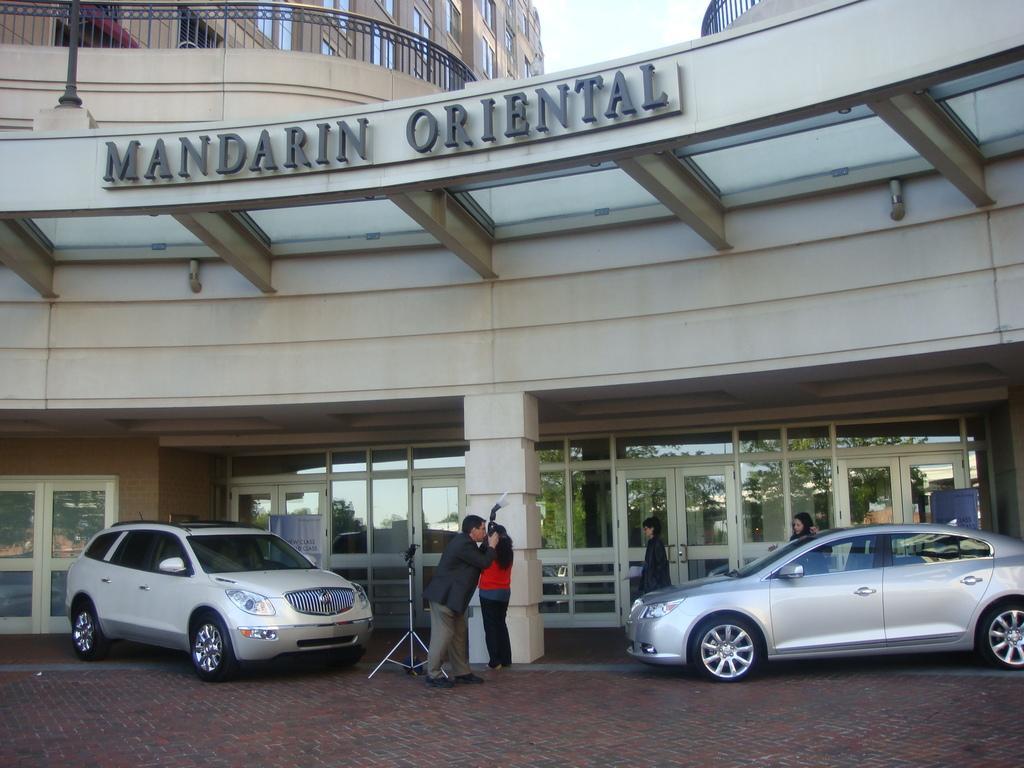Can you describe this image briefly? The picture is taken outside a building. There are two cars parked here. Few people are outside the building. There is a camera man clicking photos. There is a tripod stand over here. In the building ¨MANDARIN ORIENTAL¨is written. 